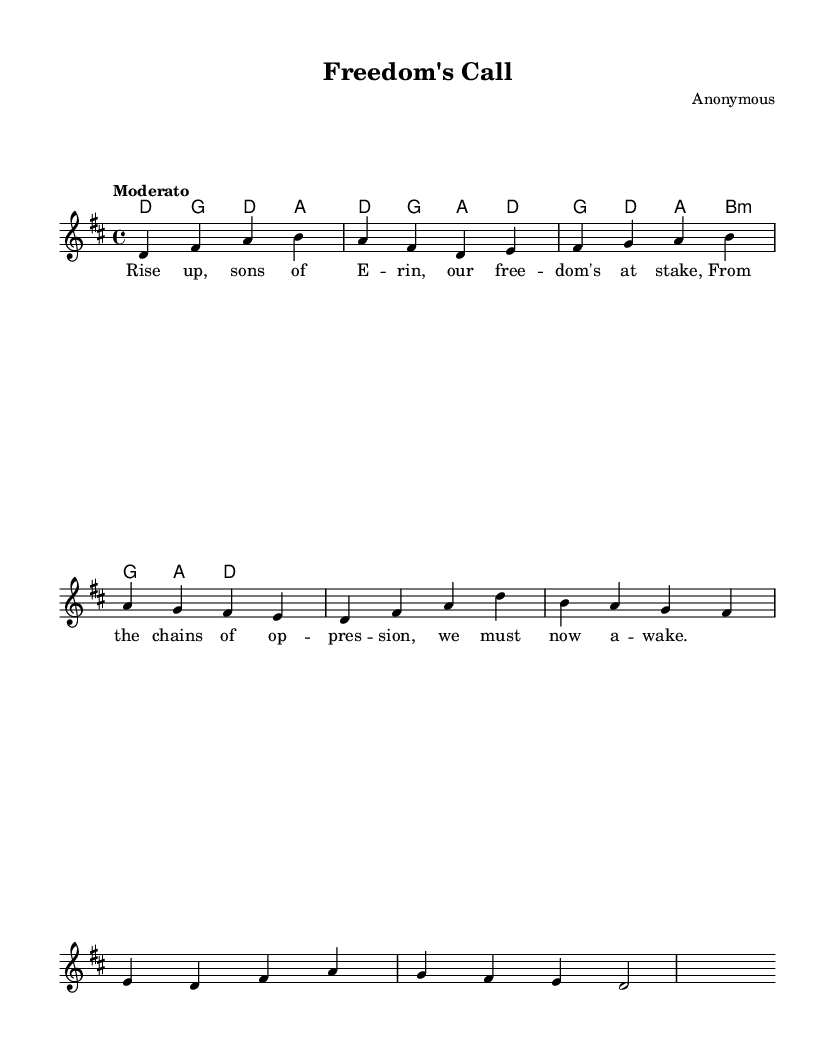What is the key signature of this music? The key signature indicates D major, which has two sharps (F# and C#). This can be seen at the beginning of the sheet music, where the key signature is indicated.
Answer: D major What is the time signature of this music? The time signature is 4/4, which means there are four beats in a measure and a quarter note gets one beat. This is clearly shown at the beginning of the music as well.
Answer: 4/4 What is the tempo marking for this piece? The tempo marking is "Moderato," which suggests a moderate pace for the performance. This is provided in the header section of the sheet music.
Answer: Moderato How many measures are in the melody? By counting the measures in the melody line, we find there are eight measures. Each measure is separated by a vertical bar line.
Answer: eight What is the first note of the melody? The first note of the melody is D, which is indicated at the beginning of the melody staff line.
Answer: D What is the type of harmony used in this piece? The harmony follows a chord mode structure that includes major chords indicated in the chord names section. This provides the harmonic accompaniment to the melody.
Answer: Major chords Who is the composer of this piece? The composer is listed as "Anonymous," indicating that the specific author of the music is not known. This is stated in the header section of the sheet music.
Answer: Anonymous 